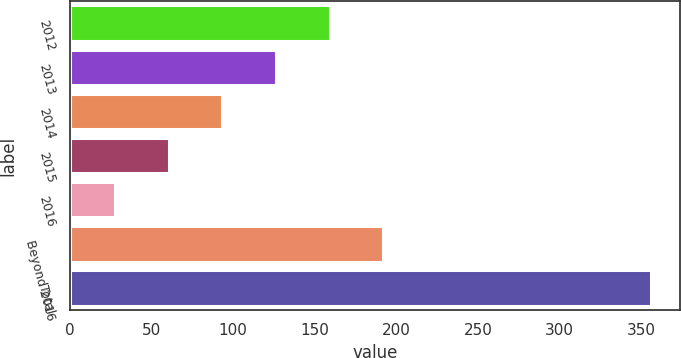<chart> <loc_0><loc_0><loc_500><loc_500><bar_chart><fcel>2012<fcel>2013<fcel>2014<fcel>2015<fcel>2016<fcel>Beyond 2016<fcel>Total<nl><fcel>159.12<fcel>126.29<fcel>93.46<fcel>60.63<fcel>27.8<fcel>191.95<fcel>356.1<nl></chart> 